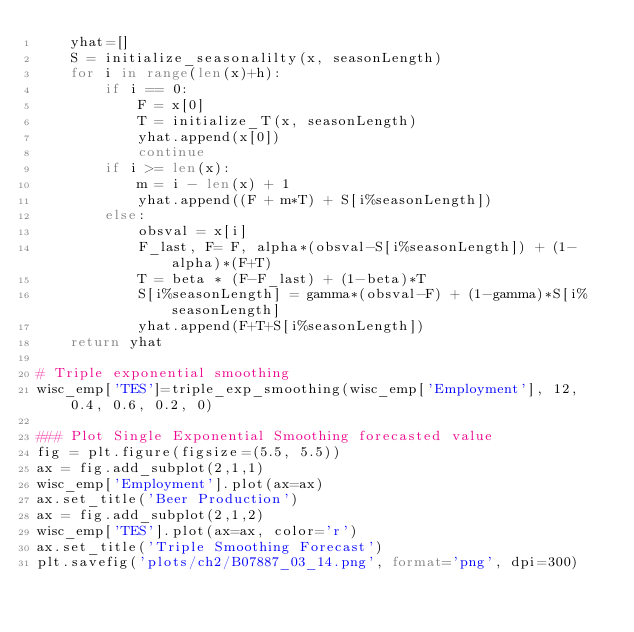<code> <loc_0><loc_0><loc_500><loc_500><_Python_>    yhat=[]
    S = initialize_seasonalilty(x, seasonLength)
    for i in range(len(x)+h):
        if i == 0:
            F = x[0]
            T = initialize_T(x, seasonLength)
            yhat.append(x[0])
            continue
        if i >= len(x):
            m = i - len(x) + 1
            yhat.append((F + m*T) + S[i%seasonLength])
        else:
            obsval = x[i]
            F_last, F= F, alpha*(obsval-S[i%seasonLength]) + (1-alpha)*(F+T)
            T = beta * (F-F_last) + (1-beta)*T
            S[i%seasonLength] = gamma*(obsval-F) + (1-gamma)*S[i%seasonLength]
            yhat.append(F+T+S[i%seasonLength])
    return yhat

# Triple exponential smoothing
wisc_emp['TES']=triple_exp_smoothing(wisc_emp['Employment'], 12, 0.4, 0.6, 0.2, 0)

### Plot Single Exponential Smoothing forecasted value
fig = plt.figure(figsize=(5.5, 5.5))
ax = fig.add_subplot(2,1,1)
wisc_emp['Employment'].plot(ax=ax)
ax.set_title('Beer Production')
ax = fig.add_subplot(2,1,2)
wisc_emp['TES'].plot(ax=ax, color='r')
ax.set_title('Triple Smoothing Forecast')
plt.savefig('plots/ch2/B07887_03_14.png', format='png', dpi=300)</code> 